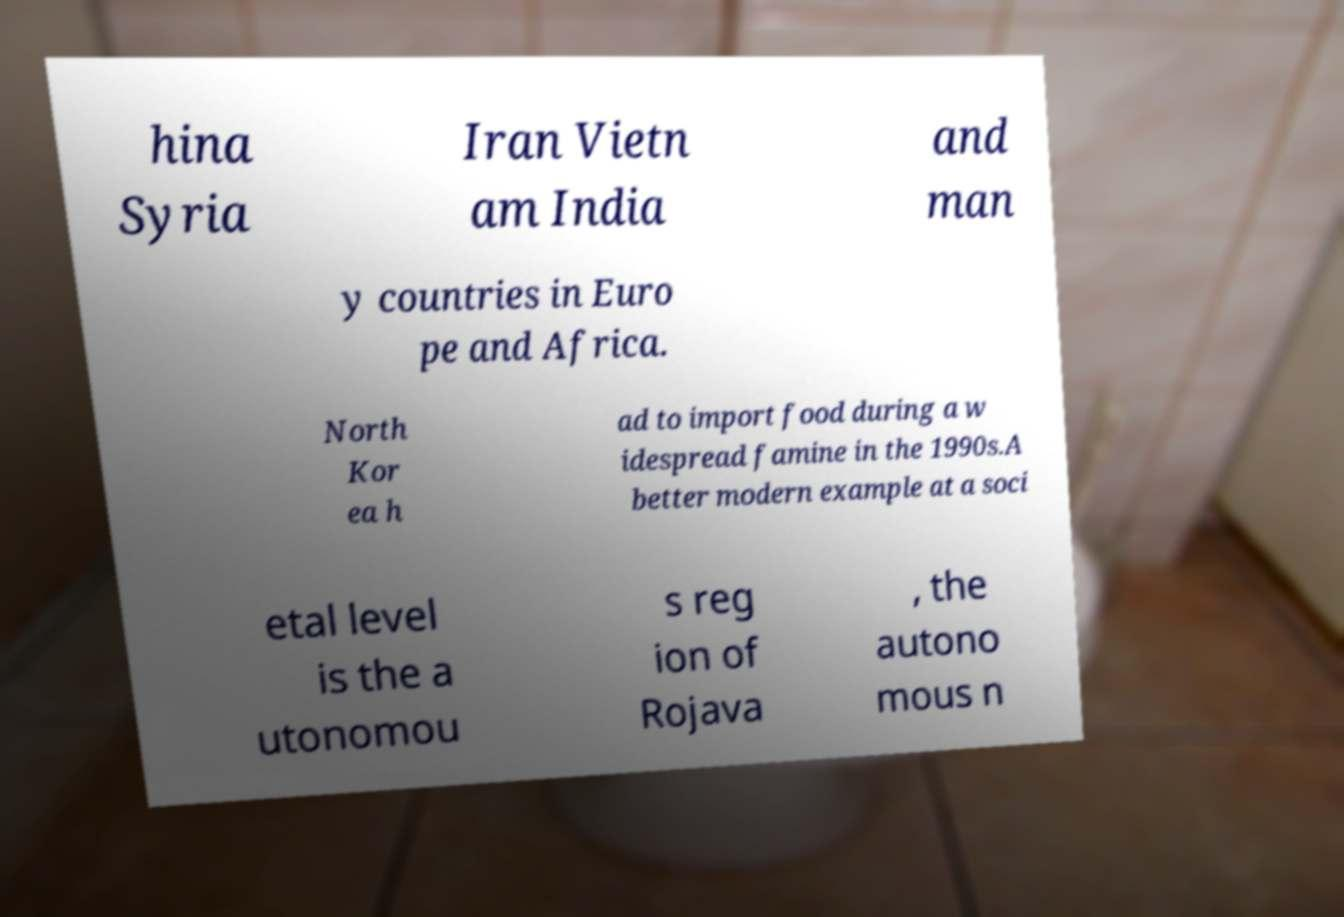I need the written content from this picture converted into text. Can you do that? hina Syria Iran Vietn am India and man y countries in Euro pe and Africa. North Kor ea h ad to import food during a w idespread famine in the 1990s.A better modern example at a soci etal level is the a utonomou s reg ion of Rojava , the autono mous n 